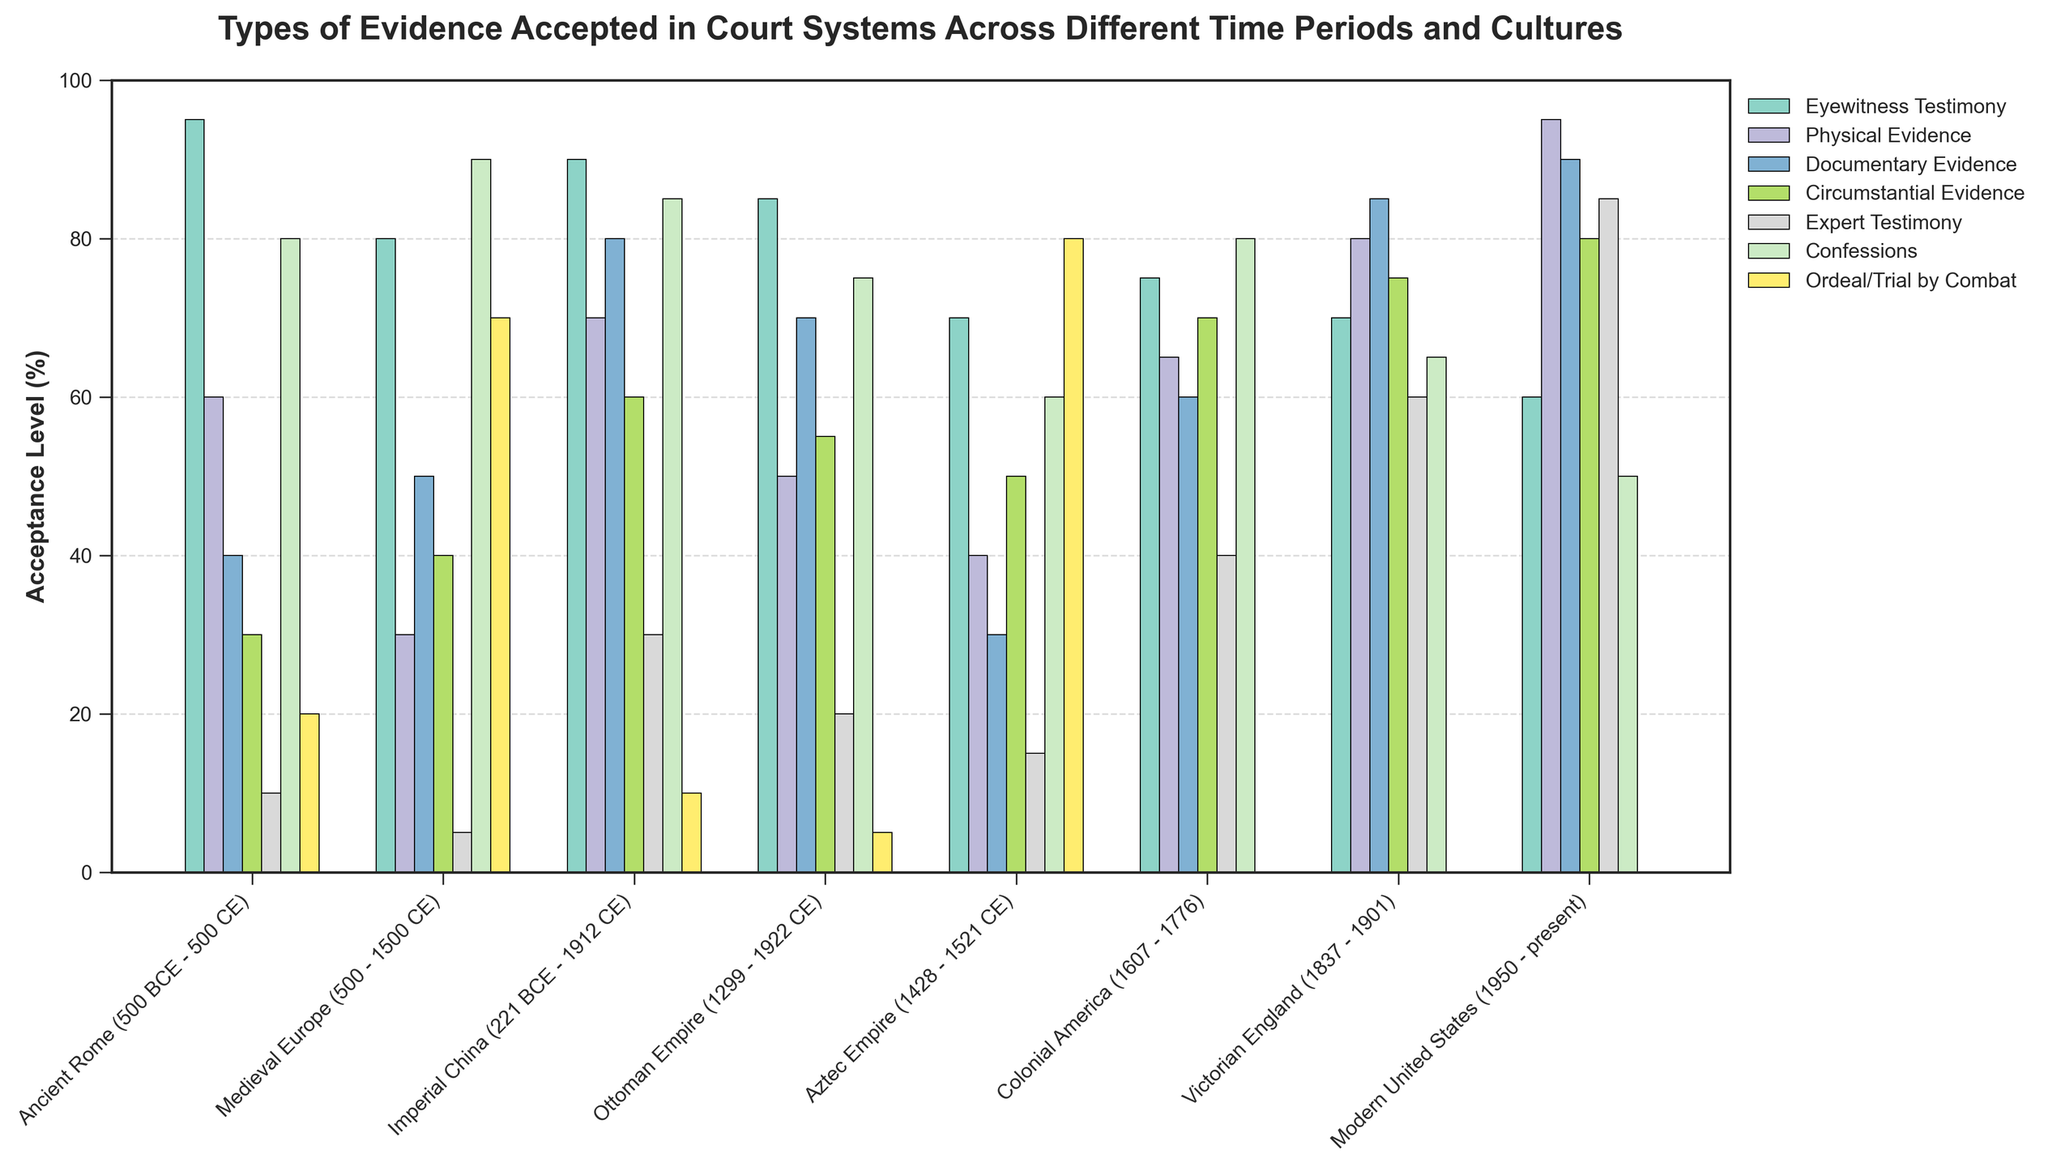Which time period had the highest acceptance of Physical Evidence? Look at the bars representing Physical Evidence across all time periods. The tallest bar indicates the highest acceptance.
Answer: Modern United States Which type of evidence saw the highest acceptance in Colonial America? Look at the bars representing different evidence types for Colonial America. The tallest bar represents the evidence type with the highest acceptance.
Answer: Circumstantial Evidence Which two time periods had the highest and lowest acceptance levels for Expert Testimony, respectively? Look at the bar heights for Expert Testimony across all time periods. Identify the time periods with the tallest and shortest bars.
Answer: Modern United States (highest), Medieval Europe (lowest) What is the average acceptance level of Eyewitness Testimony across all time periods? Add the acceptance levels of Eyewitness Testimony for all time periods and divide by the total number of periods. (95 + 80 + 90 + 85 + 70 + 75 + 70 + 60) / 8 = 78.125
Answer: 78.125 How does the acceptance of Ordeal/Trial by Combat in the Aztec Empire compare to that in Medieval Europe? Look at the heights of the bars representing Ordeal/Trial by Combat for both the Aztec Empire and Medieval Europe and compare their heights.
Answer: Higher in the Aztec Empire Which evidence type shows the most variation in acceptance levels across all time periods? Look at the bars for each evidence type across all time periods and identify the one with the largest range between the highest and lowest values.
Answer: Ordeal/Trial by Combat In which time period is Documentary Evidence almost as highly accepted as Physical Evidence? Look for a time period where the bars for Documentary Evidence and Physical Evidence are nearly of equal height.
Answer: Victorian England How does the acceptance of Confessions in Ancient Rome compare to that in the Ottoman Empire? Look at the heights of the bars representing Confessions for both Ancient Rome and the Ottoman Empire and compare their heights.
Answer: Higher in Ancient Rome What’s the combined acceptance level of Expert Testimony in Imperial China and Modern United States? Add the acceptance levels of Expert Testimony in both Imperial China and Modern United States. 30 + 85 = 115
Answer: 115 What is the difference in acceptance level of Circumstantial Evidence between Ancient Rome and Colonial America? Subtract the acceptance level of Circumstantial Evidence in Ancient Rome from that in Colonial America. 70 - 30 = 40
Answer: 40 